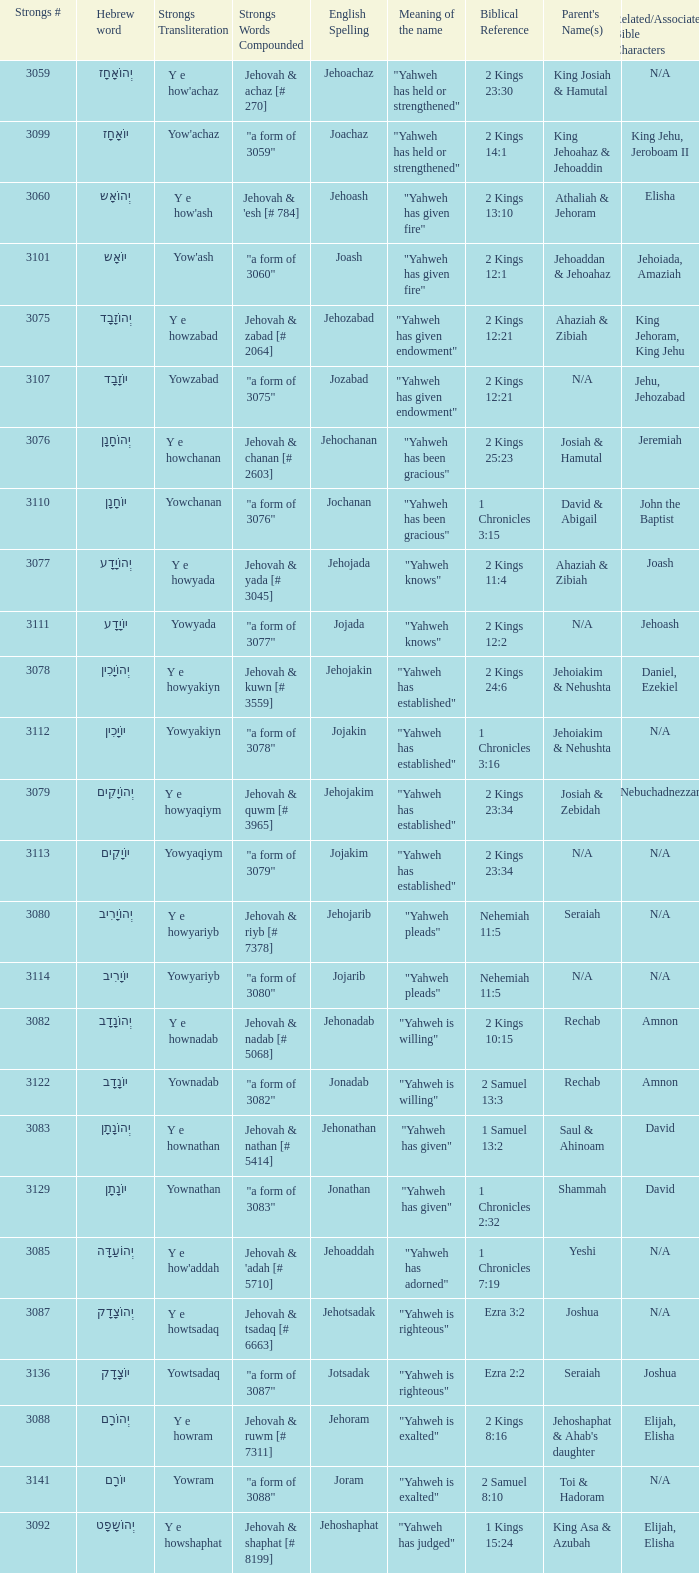What is the english spelling of the word that has the strongs trasliteration of y e howram? Jehoram. 